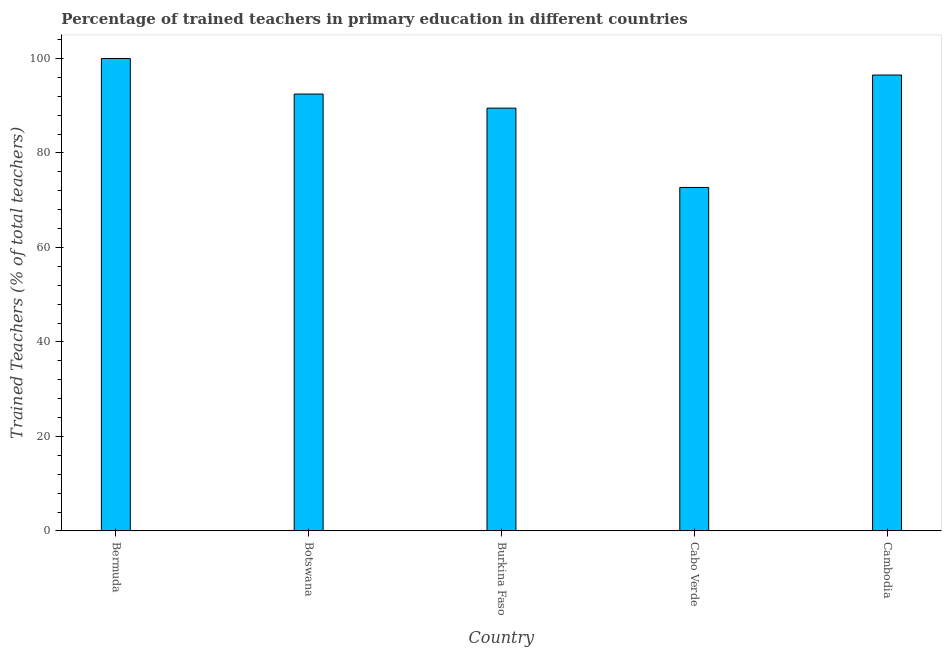Does the graph contain any zero values?
Your response must be concise. No. What is the title of the graph?
Give a very brief answer. Percentage of trained teachers in primary education in different countries. What is the label or title of the Y-axis?
Your answer should be very brief. Trained Teachers (% of total teachers). What is the percentage of trained teachers in Burkina Faso?
Give a very brief answer. 89.49. Across all countries, what is the minimum percentage of trained teachers?
Keep it short and to the point. 72.7. In which country was the percentage of trained teachers maximum?
Provide a succinct answer. Bermuda. In which country was the percentage of trained teachers minimum?
Provide a succinct answer. Cabo Verde. What is the sum of the percentage of trained teachers?
Your answer should be compact. 451.17. What is the difference between the percentage of trained teachers in Bermuda and Cabo Verde?
Provide a short and direct response. 27.3. What is the average percentage of trained teachers per country?
Offer a terse response. 90.23. What is the median percentage of trained teachers?
Your answer should be very brief. 92.47. What is the ratio of the percentage of trained teachers in Botswana to that in Cabo Verde?
Provide a succinct answer. 1.27. Is the percentage of trained teachers in Cabo Verde less than that in Cambodia?
Provide a short and direct response. Yes. What is the difference between the highest and the second highest percentage of trained teachers?
Offer a very short reply. 3.5. What is the difference between the highest and the lowest percentage of trained teachers?
Ensure brevity in your answer.  27.3. In how many countries, is the percentage of trained teachers greater than the average percentage of trained teachers taken over all countries?
Offer a very short reply. 3. How many bars are there?
Your answer should be compact. 5. What is the difference between two consecutive major ticks on the Y-axis?
Give a very brief answer. 20. Are the values on the major ticks of Y-axis written in scientific E-notation?
Make the answer very short. No. What is the Trained Teachers (% of total teachers) of Botswana?
Offer a terse response. 92.47. What is the Trained Teachers (% of total teachers) in Burkina Faso?
Ensure brevity in your answer.  89.49. What is the Trained Teachers (% of total teachers) in Cabo Verde?
Offer a terse response. 72.7. What is the Trained Teachers (% of total teachers) of Cambodia?
Your response must be concise. 96.5. What is the difference between the Trained Teachers (% of total teachers) in Bermuda and Botswana?
Keep it short and to the point. 7.53. What is the difference between the Trained Teachers (% of total teachers) in Bermuda and Burkina Faso?
Your response must be concise. 10.51. What is the difference between the Trained Teachers (% of total teachers) in Bermuda and Cabo Verde?
Offer a very short reply. 27.3. What is the difference between the Trained Teachers (% of total teachers) in Bermuda and Cambodia?
Offer a very short reply. 3.5. What is the difference between the Trained Teachers (% of total teachers) in Botswana and Burkina Faso?
Keep it short and to the point. 2.98. What is the difference between the Trained Teachers (% of total teachers) in Botswana and Cabo Verde?
Give a very brief answer. 19.77. What is the difference between the Trained Teachers (% of total teachers) in Botswana and Cambodia?
Provide a short and direct response. -4.03. What is the difference between the Trained Teachers (% of total teachers) in Burkina Faso and Cabo Verde?
Make the answer very short. 16.79. What is the difference between the Trained Teachers (% of total teachers) in Burkina Faso and Cambodia?
Ensure brevity in your answer.  -7.01. What is the difference between the Trained Teachers (% of total teachers) in Cabo Verde and Cambodia?
Your response must be concise. -23.8. What is the ratio of the Trained Teachers (% of total teachers) in Bermuda to that in Botswana?
Your response must be concise. 1.08. What is the ratio of the Trained Teachers (% of total teachers) in Bermuda to that in Burkina Faso?
Your answer should be compact. 1.12. What is the ratio of the Trained Teachers (% of total teachers) in Bermuda to that in Cabo Verde?
Ensure brevity in your answer.  1.38. What is the ratio of the Trained Teachers (% of total teachers) in Bermuda to that in Cambodia?
Give a very brief answer. 1.04. What is the ratio of the Trained Teachers (% of total teachers) in Botswana to that in Burkina Faso?
Give a very brief answer. 1.03. What is the ratio of the Trained Teachers (% of total teachers) in Botswana to that in Cabo Verde?
Offer a terse response. 1.27. What is the ratio of the Trained Teachers (% of total teachers) in Botswana to that in Cambodia?
Offer a very short reply. 0.96. What is the ratio of the Trained Teachers (% of total teachers) in Burkina Faso to that in Cabo Verde?
Your answer should be compact. 1.23. What is the ratio of the Trained Teachers (% of total teachers) in Burkina Faso to that in Cambodia?
Make the answer very short. 0.93. What is the ratio of the Trained Teachers (% of total teachers) in Cabo Verde to that in Cambodia?
Offer a very short reply. 0.75. 